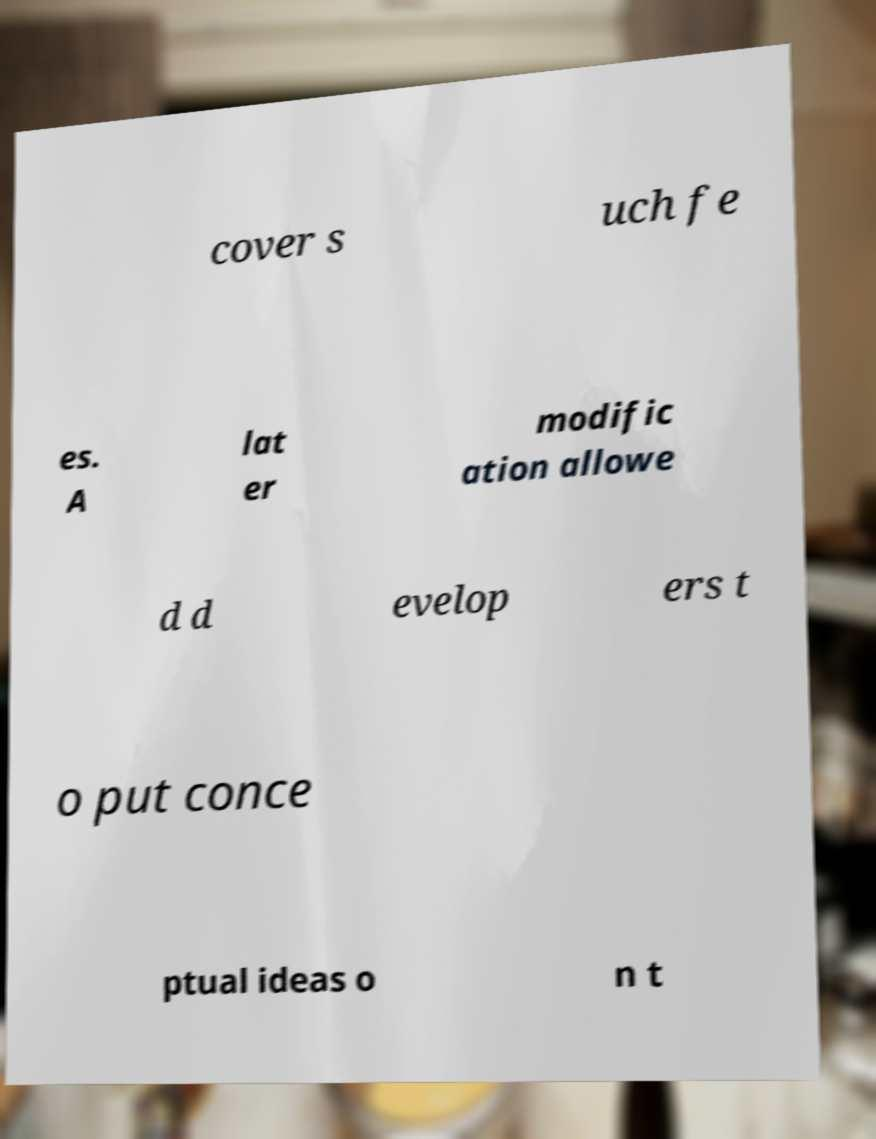Can you accurately transcribe the text from the provided image for me? cover s uch fe es. A lat er modific ation allowe d d evelop ers t o put conce ptual ideas o n t 